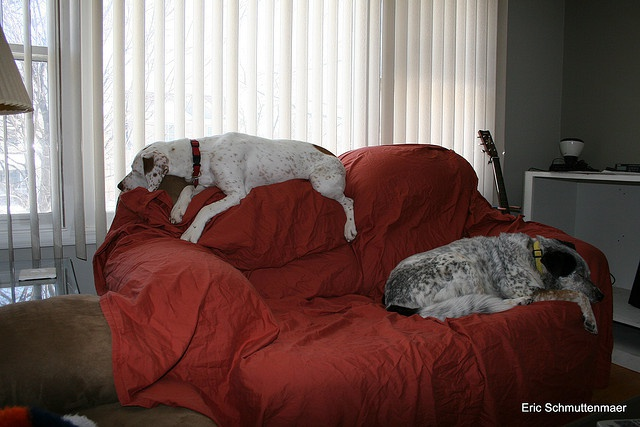Describe the objects in this image and their specific colors. I can see couch in lavender, maroon, black, and brown tones, dog in lavender, gray, black, and darkgreen tones, dog in lavender, darkgray, gray, and black tones, tv in black and lavender tones, and bowl in lavender, gray, and black tones in this image. 